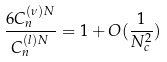Convert formula to latex. <formula><loc_0><loc_0><loc_500><loc_500>\frac { 6 C _ { n } ^ { ( \nu ) N } } { C _ { n } ^ { ( l ) N } } = 1 + O ( \frac { 1 } { N _ { c } ^ { 2 } } )</formula> 